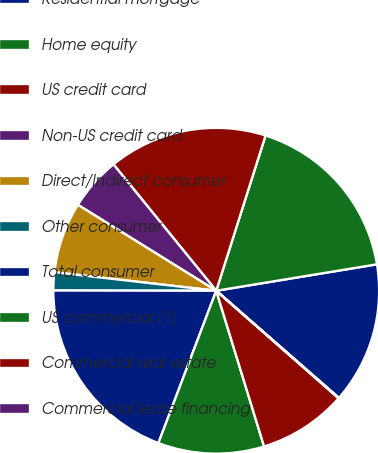Convert chart. <chart><loc_0><loc_0><loc_500><loc_500><pie_chart><fcel>Residential mortgage<fcel>Home equity<fcel>US credit card<fcel>Non-US credit card<fcel>Direct/Indirect consumer<fcel>Other consumer<fcel>Total consumer<fcel>US commercial (1)<fcel>Commercial real estate<fcel>Commercial lease financing<nl><fcel>14.02%<fcel>17.51%<fcel>15.76%<fcel>5.29%<fcel>7.03%<fcel>1.79%<fcel>19.25%<fcel>10.52%<fcel>8.78%<fcel>0.05%<nl></chart> 